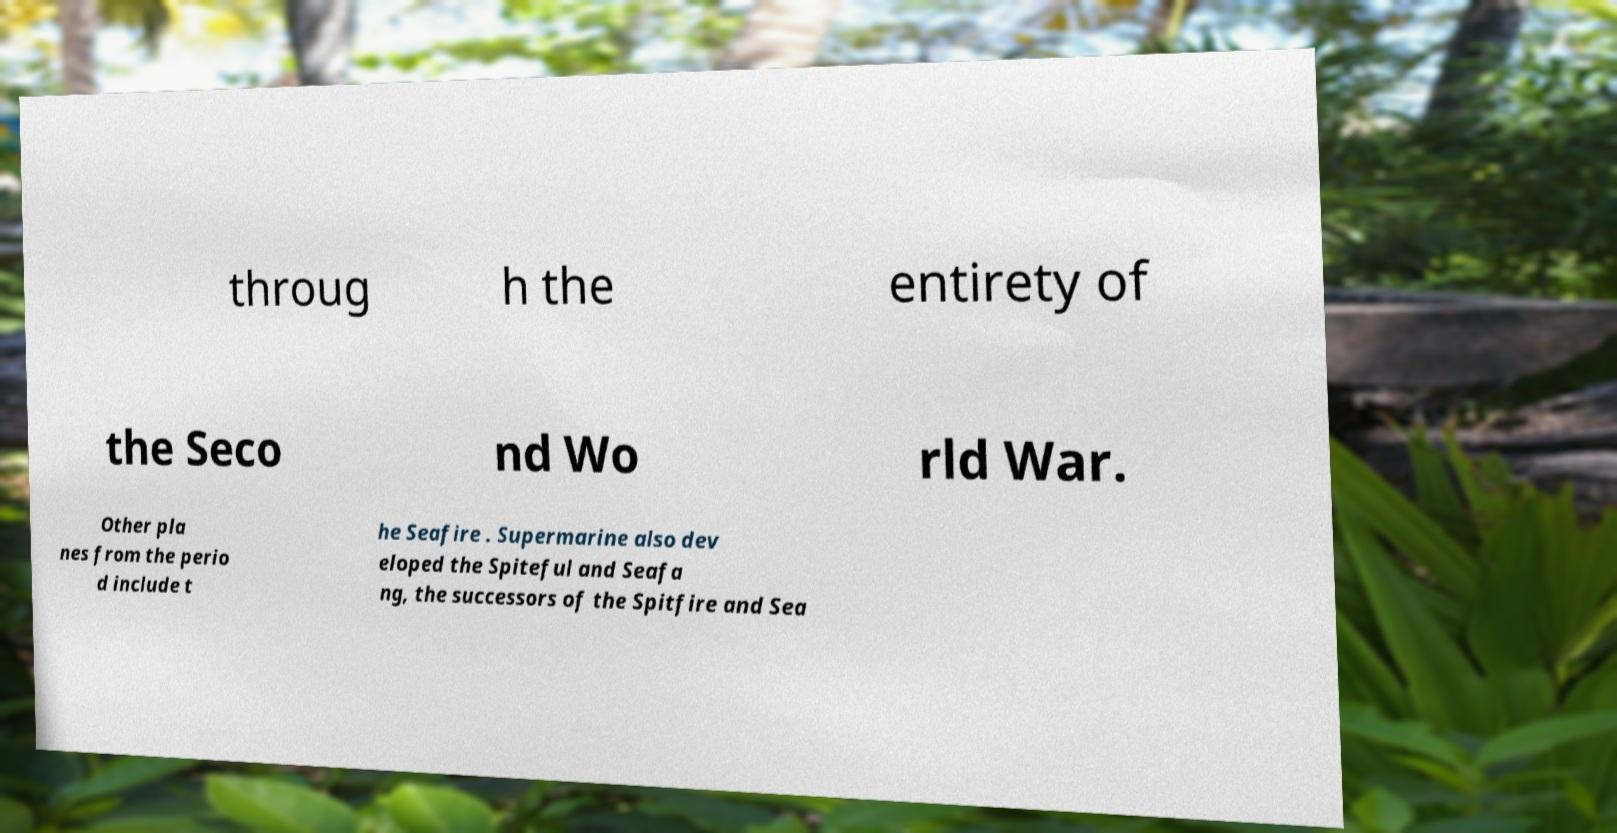For documentation purposes, I need the text within this image transcribed. Could you provide that? throug h the entirety of the Seco nd Wo rld War. Other pla nes from the perio d include t he Seafire . Supermarine also dev eloped the Spiteful and Seafa ng, the successors of the Spitfire and Sea 